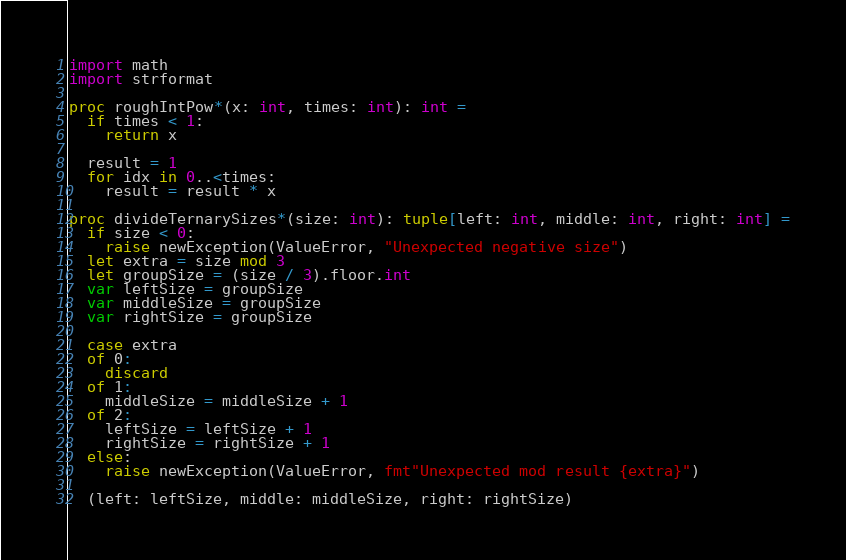Convert code to text. <code><loc_0><loc_0><loc_500><loc_500><_Nim_>
import math
import strformat

proc roughIntPow*(x: int, times: int): int =
  if times < 1:
    return x

  result = 1
  for idx in 0..<times:
    result = result * x

proc divideTernarySizes*(size: int): tuple[left: int, middle: int, right: int] =
  if size < 0:
    raise newException(ValueError, "Unexpected negative size")
  let extra = size mod 3
  let groupSize = (size / 3).floor.int
  var leftSize = groupSize
  var middleSize = groupSize
  var rightSize = groupSize

  case extra
  of 0:
    discard
  of 1:
    middleSize = middleSize + 1
  of 2:
    leftSize = leftSize + 1
    rightSize = rightSize + 1
  else:
    raise newException(ValueError, fmt"Unexpected mod result {extra}")

  (left: leftSize, middle: middleSize, right: rightSize)
</code> 